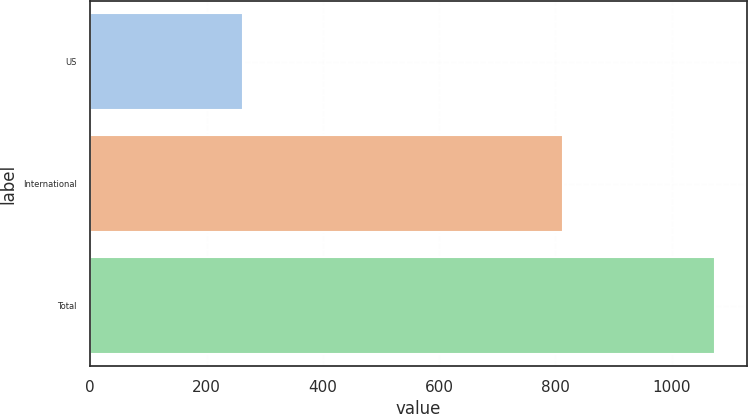Convert chart to OTSL. <chart><loc_0><loc_0><loc_500><loc_500><bar_chart><fcel>US<fcel>International<fcel>Total<nl><fcel>262<fcel>813<fcel>1075<nl></chart> 